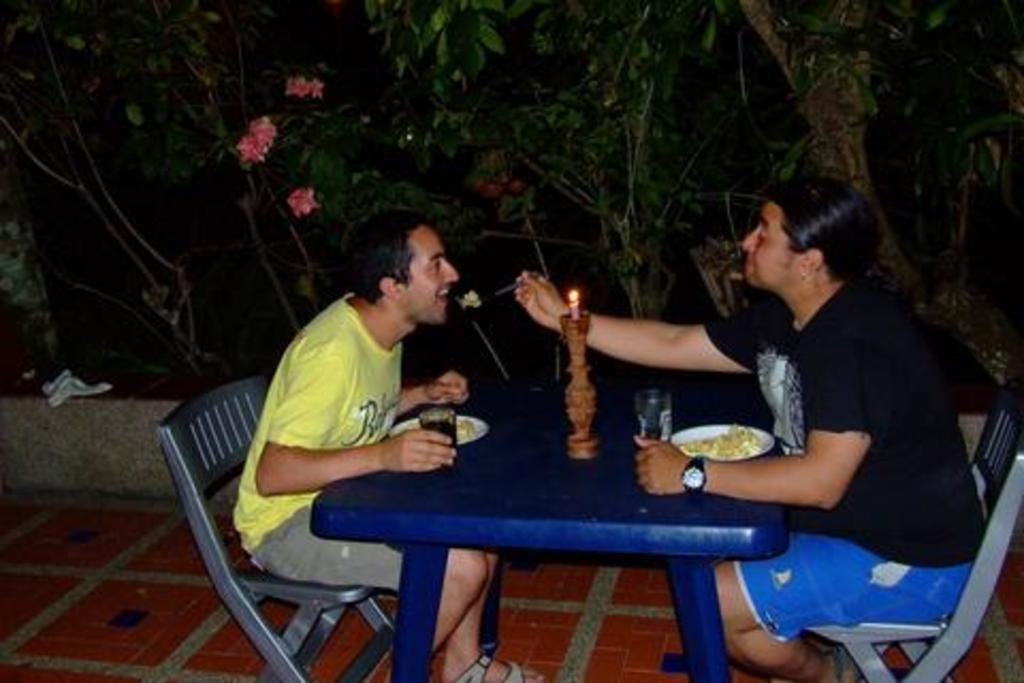How many people are in the image? There are two men in the image. What are the men doing in the image? The men are sitting in chairs. What objects can be seen in the image besides the men? There is a candle, a glass, food on a plate, flowers on a tree, and a white cloth in the image. What type of feather can be seen on the laborer's hat in the image? There is no laborer or feather present in the image. What is the cause of the candle's flame in the image? The cause of the candle's flame is not visible in the image, but it is likely due to the presence of a lit wick. 